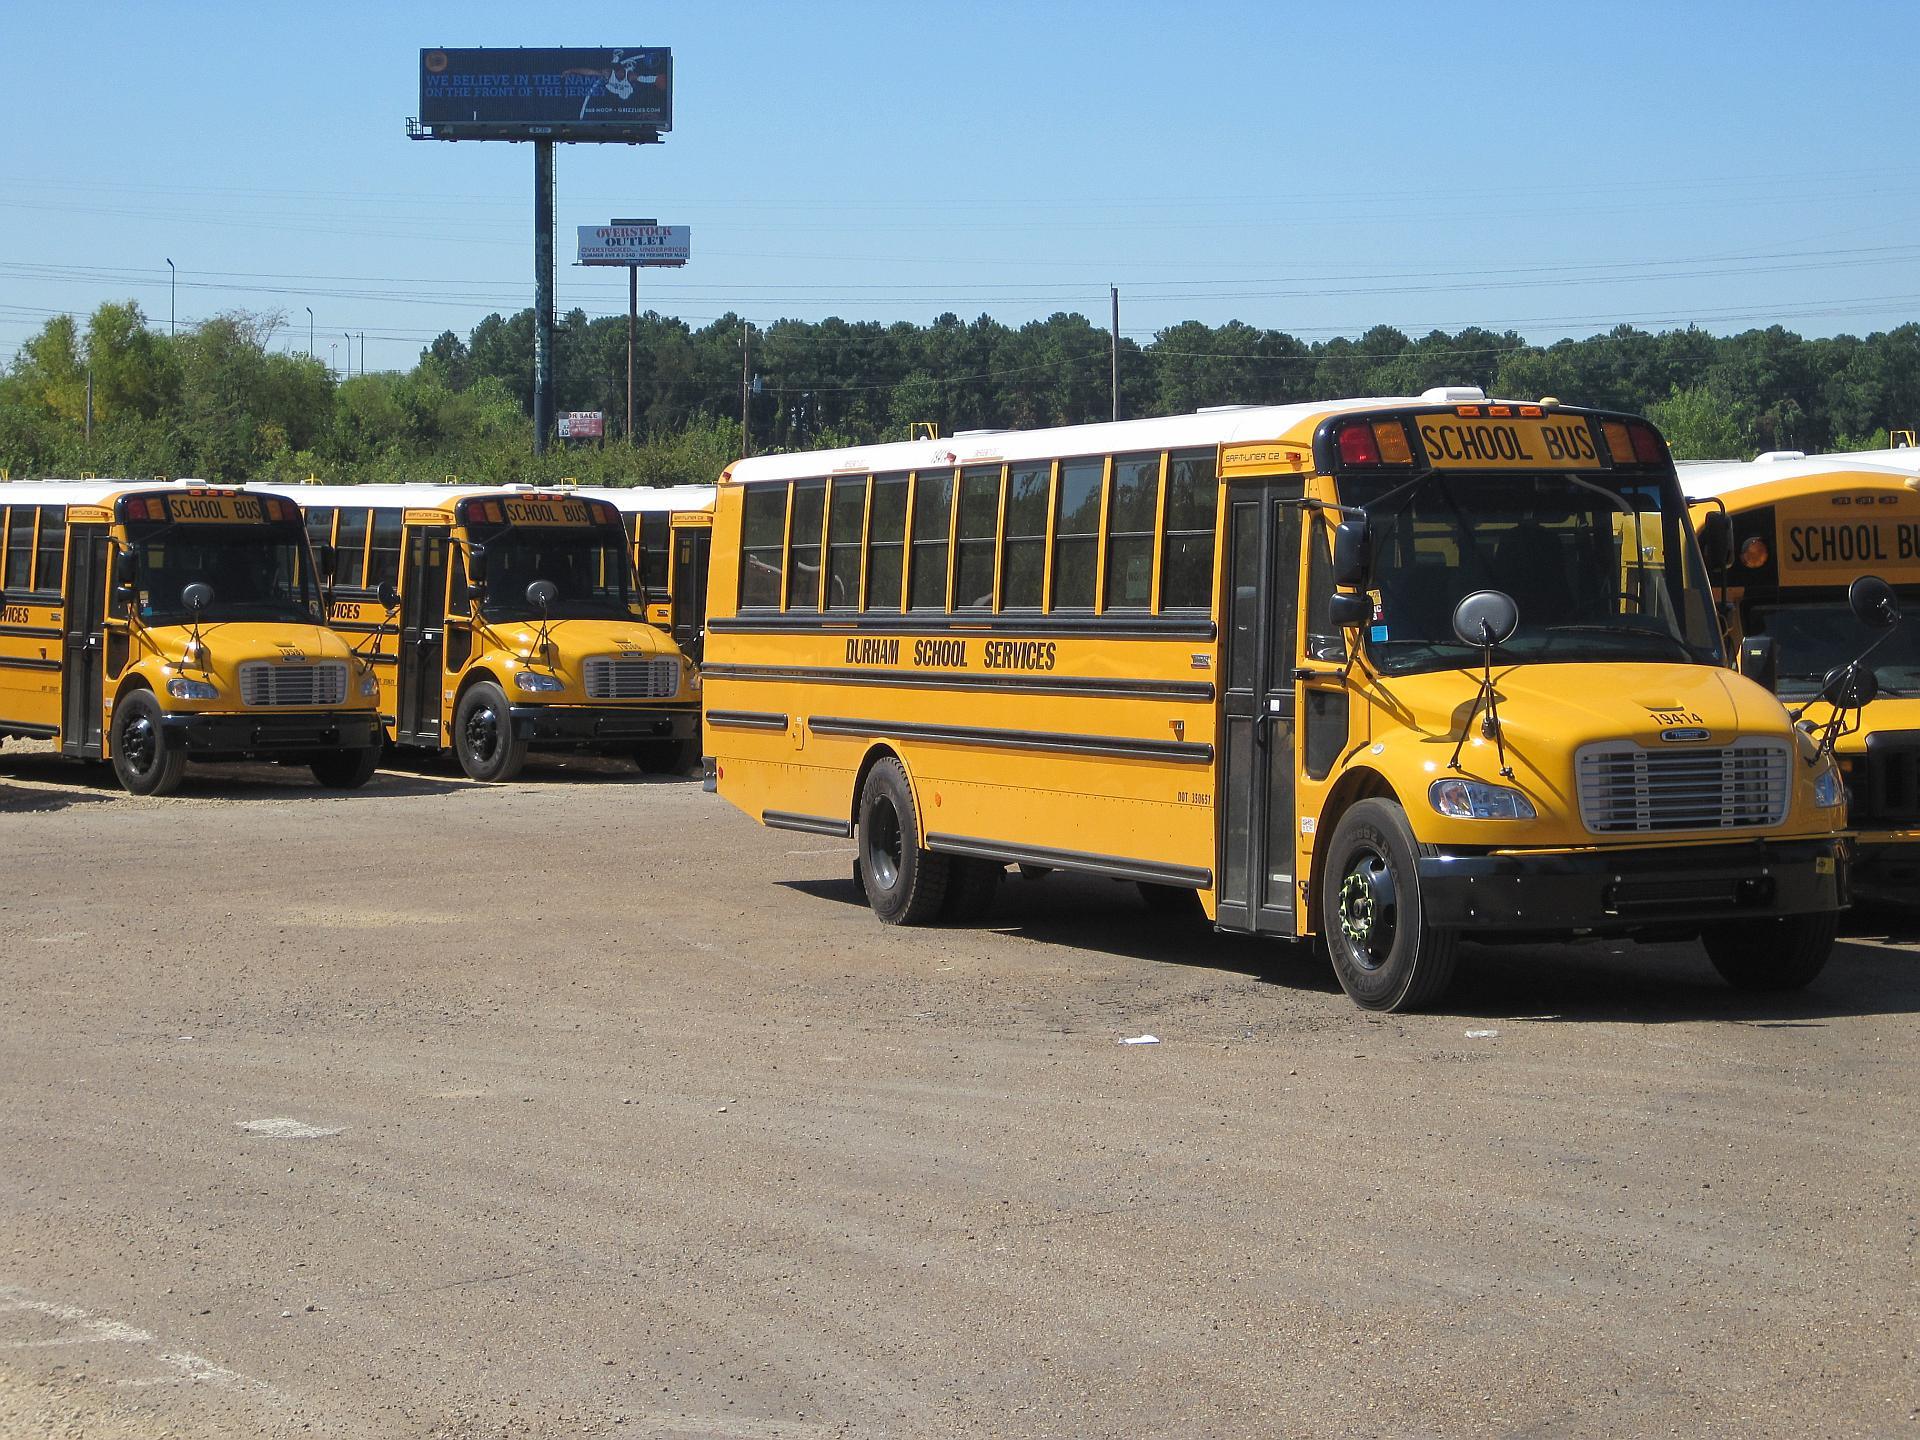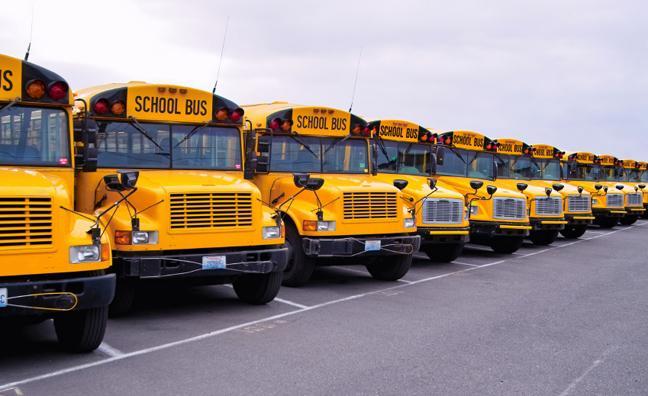The first image is the image on the left, the second image is the image on the right. Examine the images to the left and right. Is the description "At least one image shows buses with forward-turned non-flat fronts parked side-by-side in a row and angled facing rightward." accurate? Answer yes or no. Yes. The first image is the image on the left, the second image is the image on the right. Considering the images on both sides, is "Some buses have front license plates." valid? Answer yes or no. Yes. 